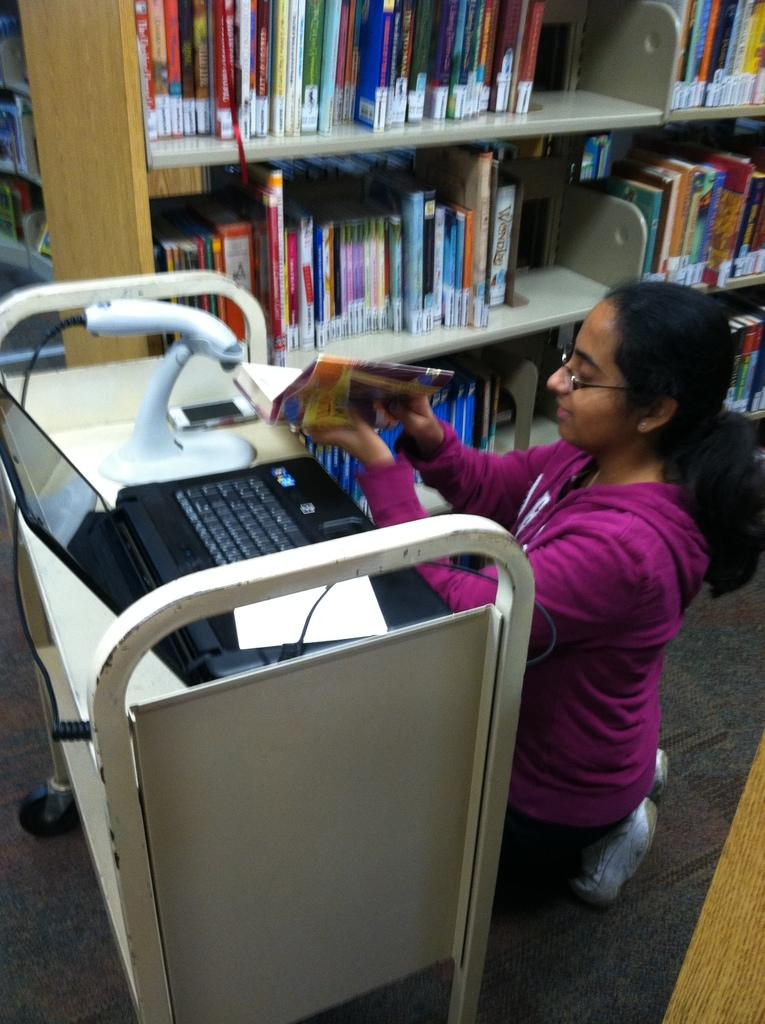What electronic device is visible in the image? There is a laptop in the image. What else can be seen in the image besides the laptop? There is another electronic device, which is a mobile on a cart wheel, visible in the image. What is the woman in the image holding? The woman is holding a book in her hands. What can be seen in the background of the image? There are books on racks in the background of the image. What type of wood can be seen floating in the lake in the image? There is no lake or wood present in the image; it features a laptop, a mobile on a cart wheel, a woman holding a book, and books on racks. 